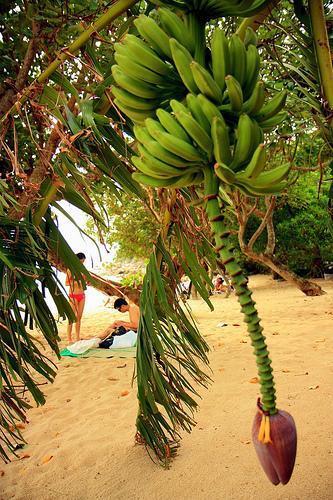How many people are sitting?
Give a very brief answer. 1. 